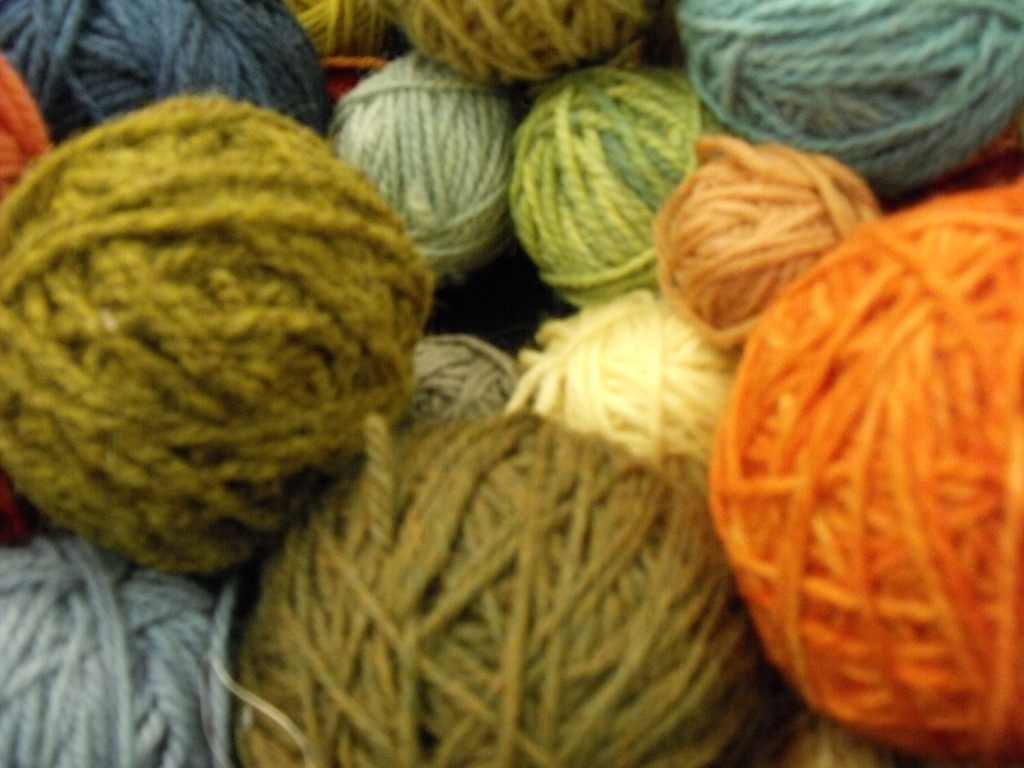What do you think is the best use for the materials shown in the image? The yarns shown in the image would be excellent for handcrafted textiles such as sweaters, scarves, hats, or blankets. Given the texture and color variety, they're especially suitable for projects that require warmth and comfort, as well as those that benefit from a splash of color to brighten up the cooler months or for making decorative items for the home. 